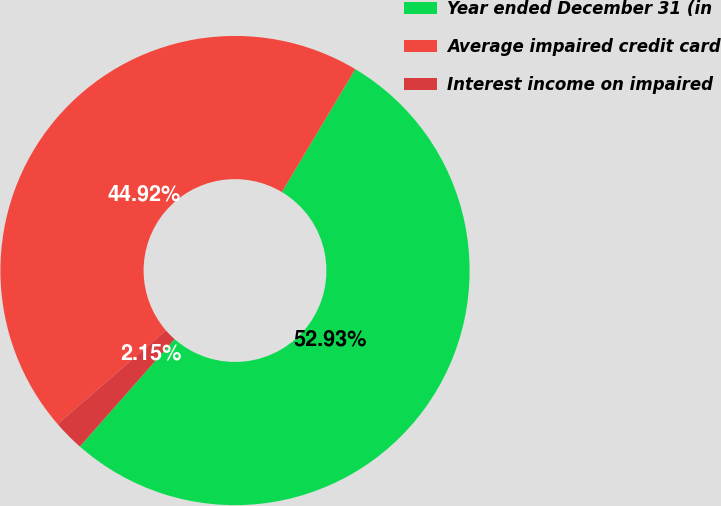<chart> <loc_0><loc_0><loc_500><loc_500><pie_chart><fcel>Year ended December 31 (in<fcel>Average impaired credit card<fcel>Interest income on impaired<nl><fcel>52.93%<fcel>44.92%<fcel>2.15%<nl></chart> 